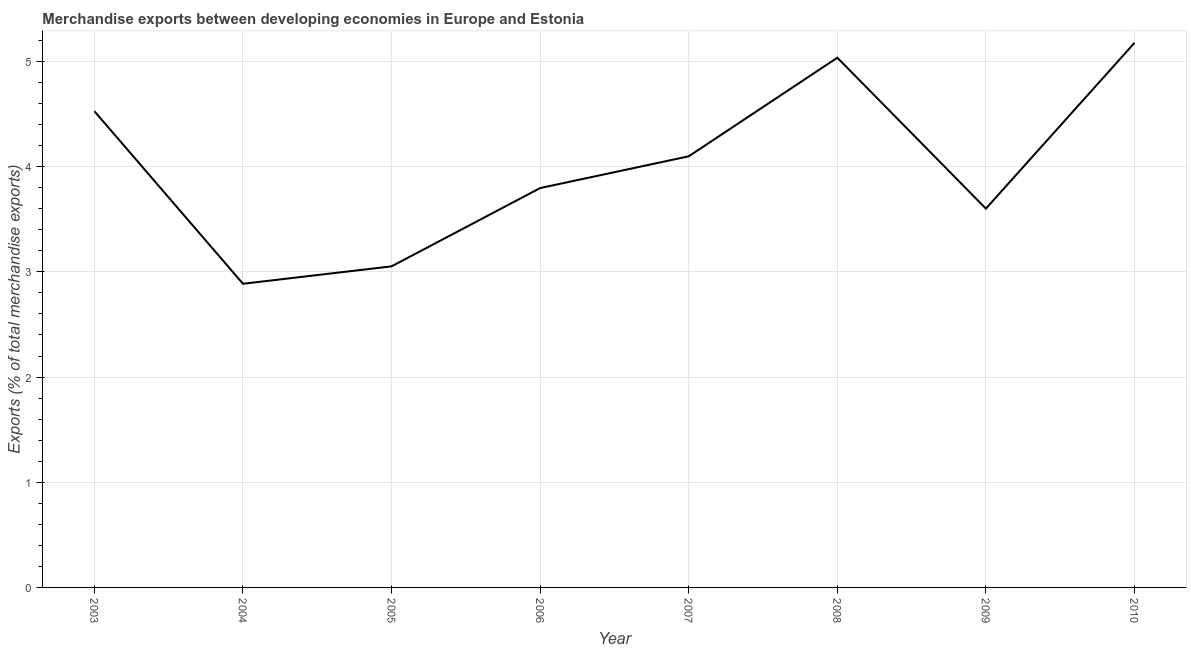What is the merchandise exports in 2005?
Offer a terse response. 3.05. Across all years, what is the maximum merchandise exports?
Offer a very short reply. 5.18. Across all years, what is the minimum merchandise exports?
Your response must be concise. 2.89. In which year was the merchandise exports maximum?
Keep it short and to the point. 2010. What is the sum of the merchandise exports?
Your response must be concise. 32.17. What is the difference between the merchandise exports in 2004 and 2007?
Your answer should be compact. -1.21. What is the average merchandise exports per year?
Provide a short and direct response. 4.02. What is the median merchandise exports?
Ensure brevity in your answer.  3.95. Do a majority of the years between 2010 and 2003 (inclusive) have merchandise exports greater than 0.4 %?
Keep it short and to the point. Yes. What is the ratio of the merchandise exports in 2005 to that in 2009?
Offer a terse response. 0.85. Is the merchandise exports in 2005 less than that in 2010?
Your answer should be very brief. Yes. Is the difference between the merchandise exports in 2003 and 2004 greater than the difference between any two years?
Give a very brief answer. No. What is the difference between the highest and the second highest merchandise exports?
Make the answer very short. 0.14. Is the sum of the merchandise exports in 2004 and 2010 greater than the maximum merchandise exports across all years?
Provide a short and direct response. Yes. What is the difference between the highest and the lowest merchandise exports?
Your answer should be compact. 2.29. Does the merchandise exports monotonically increase over the years?
Offer a very short reply. No. Are the values on the major ticks of Y-axis written in scientific E-notation?
Provide a succinct answer. No. Does the graph contain any zero values?
Keep it short and to the point. No. Does the graph contain grids?
Make the answer very short. Yes. What is the title of the graph?
Make the answer very short. Merchandise exports between developing economies in Europe and Estonia. What is the label or title of the X-axis?
Provide a succinct answer. Year. What is the label or title of the Y-axis?
Ensure brevity in your answer.  Exports (% of total merchandise exports). What is the Exports (% of total merchandise exports) in 2003?
Make the answer very short. 4.53. What is the Exports (% of total merchandise exports) of 2004?
Give a very brief answer. 2.89. What is the Exports (% of total merchandise exports) of 2005?
Offer a very short reply. 3.05. What is the Exports (% of total merchandise exports) of 2006?
Give a very brief answer. 3.8. What is the Exports (% of total merchandise exports) of 2007?
Offer a very short reply. 4.1. What is the Exports (% of total merchandise exports) in 2008?
Offer a terse response. 5.04. What is the Exports (% of total merchandise exports) of 2009?
Give a very brief answer. 3.6. What is the Exports (% of total merchandise exports) of 2010?
Make the answer very short. 5.18. What is the difference between the Exports (% of total merchandise exports) in 2003 and 2004?
Provide a short and direct response. 1.64. What is the difference between the Exports (% of total merchandise exports) in 2003 and 2005?
Make the answer very short. 1.47. What is the difference between the Exports (% of total merchandise exports) in 2003 and 2006?
Offer a terse response. 0.73. What is the difference between the Exports (% of total merchandise exports) in 2003 and 2007?
Provide a short and direct response. 0.43. What is the difference between the Exports (% of total merchandise exports) in 2003 and 2008?
Your response must be concise. -0.51. What is the difference between the Exports (% of total merchandise exports) in 2003 and 2009?
Offer a very short reply. 0.93. What is the difference between the Exports (% of total merchandise exports) in 2003 and 2010?
Offer a very short reply. -0.65. What is the difference between the Exports (% of total merchandise exports) in 2004 and 2005?
Provide a succinct answer. -0.17. What is the difference between the Exports (% of total merchandise exports) in 2004 and 2006?
Keep it short and to the point. -0.91. What is the difference between the Exports (% of total merchandise exports) in 2004 and 2007?
Make the answer very short. -1.21. What is the difference between the Exports (% of total merchandise exports) in 2004 and 2008?
Your response must be concise. -2.15. What is the difference between the Exports (% of total merchandise exports) in 2004 and 2009?
Your response must be concise. -0.71. What is the difference between the Exports (% of total merchandise exports) in 2004 and 2010?
Offer a very short reply. -2.29. What is the difference between the Exports (% of total merchandise exports) in 2005 and 2006?
Provide a short and direct response. -0.74. What is the difference between the Exports (% of total merchandise exports) in 2005 and 2007?
Your answer should be very brief. -1.05. What is the difference between the Exports (% of total merchandise exports) in 2005 and 2008?
Offer a very short reply. -1.98. What is the difference between the Exports (% of total merchandise exports) in 2005 and 2009?
Make the answer very short. -0.55. What is the difference between the Exports (% of total merchandise exports) in 2005 and 2010?
Offer a terse response. -2.12. What is the difference between the Exports (% of total merchandise exports) in 2006 and 2007?
Your answer should be compact. -0.3. What is the difference between the Exports (% of total merchandise exports) in 2006 and 2008?
Provide a short and direct response. -1.24. What is the difference between the Exports (% of total merchandise exports) in 2006 and 2009?
Provide a succinct answer. 0.2. What is the difference between the Exports (% of total merchandise exports) in 2006 and 2010?
Make the answer very short. -1.38. What is the difference between the Exports (% of total merchandise exports) in 2007 and 2008?
Provide a short and direct response. -0.94. What is the difference between the Exports (% of total merchandise exports) in 2007 and 2009?
Your answer should be compact. 0.5. What is the difference between the Exports (% of total merchandise exports) in 2007 and 2010?
Make the answer very short. -1.08. What is the difference between the Exports (% of total merchandise exports) in 2008 and 2009?
Offer a very short reply. 1.43. What is the difference between the Exports (% of total merchandise exports) in 2008 and 2010?
Provide a succinct answer. -0.14. What is the difference between the Exports (% of total merchandise exports) in 2009 and 2010?
Provide a succinct answer. -1.58. What is the ratio of the Exports (% of total merchandise exports) in 2003 to that in 2004?
Offer a terse response. 1.57. What is the ratio of the Exports (% of total merchandise exports) in 2003 to that in 2005?
Your response must be concise. 1.48. What is the ratio of the Exports (% of total merchandise exports) in 2003 to that in 2006?
Your answer should be very brief. 1.19. What is the ratio of the Exports (% of total merchandise exports) in 2003 to that in 2007?
Your response must be concise. 1.1. What is the ratio of the Exports (% of total merchandise exports) in 2003 to that in 2008?
Your response must be concise. 0.9. What is the ratio of the Exports (% of total merchandise exports) in 2003 to that in 2009?
Offer a very short reply. 1.26. What is the ratio of the Exports (% of total merchandise exports) in 2003 to that in 2010?
Provide a succinct answer. 0.87. What is the ratio of the Exports (% of total merchandise exports) in 2004 to that in 2005?
Offer a very short reply. 0.95. What is the ratio of the Exports (% of total merchandise exports) in 2004 to that in 2006?
Keep it short and to the point. 0.76. What is the ratio of the Exports (% of total merchandise exports) in 2004 to that in 2007?
Keep it short and to the point. 0.7. What is the ratio of the Exports (% of total merchandise exports) in 2004 to that in 2008?
Ensure brevity in your answer.  0.57. What is the ratio of the Exports (% of total merchandise exports) in 2004 to that in 2009?
Your answer should be compact. 0.8. What is the ratio of the Exports (% of total merchandise exports) in 2004 to that in 2010?
Offer a very short reply. 0.56. What is the ratio of the Exports (% of total merchandise exports) in 2005 to that in 2006?
Offer a very short reply. 0.8. What is the ratio of the Exports (% of total merchandise exports) in 2005 to that in 2007?
Give a very brief answer. 0.74. What is the ratio of the Exports (% of total merchandise exports) in 2005 to that in 2008?
Give a very brief answer. 0.61. What is the ratio of the Exports (% of total merchandise exports) in 2005 to that in 2009?
Your answer should be compact. 0.85. What is the ratio of the Exports (% of total merchandise exports) in 2005 to that in 2010?
Give a very brief answer. 0.59. What is the ratio of the Exports (% of total merchandise exports) in 2006 to that in 2007?
Provide a succinct answer. 0.93. What is the ratio of the Exports (% of total merchandise exports) in 2006 to that in 2008?
Your answer should be compact. 0.75. What is the ratio of the Exports (% of total merchandise exports) in 2006 to that in 2009?
Provide a succinct answer. 1.05. What is the ratio of the Exports (% of total merchandise exports) in 2006 to that in 2010?
Give a very brief answer. 0.73. What is the ratio of the Exports (% of total merchandise exports) in 2007 to that in 2008?
Offer a terse response. 0.81. What is the ratio of the Exports (% of total merchandise exports) in 2007 to that in 2009?
Ensure brevity in your answer.  1.14. What is the ratio of the Exports (% of total merchandise exports) in 2007 to that in 2010?
Make the answer very short. 0.79. What is the ratio of the Exports (% of total merchandise exports) in 2008 to that in 2009?
Give a very brief answer. 1.4. What is the ratio of the Exports (% of total merchandise exports) in 2009 to that in 2010?
Ensure brevity in your answer.  0.7. 